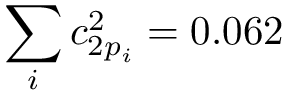<formula> <loc_0><loc_0><loc_500><loc_500>\sum _ { i } c _ { 2 p _ { i } } ^ { 2 } = 0 . 0 6 2</formula> 